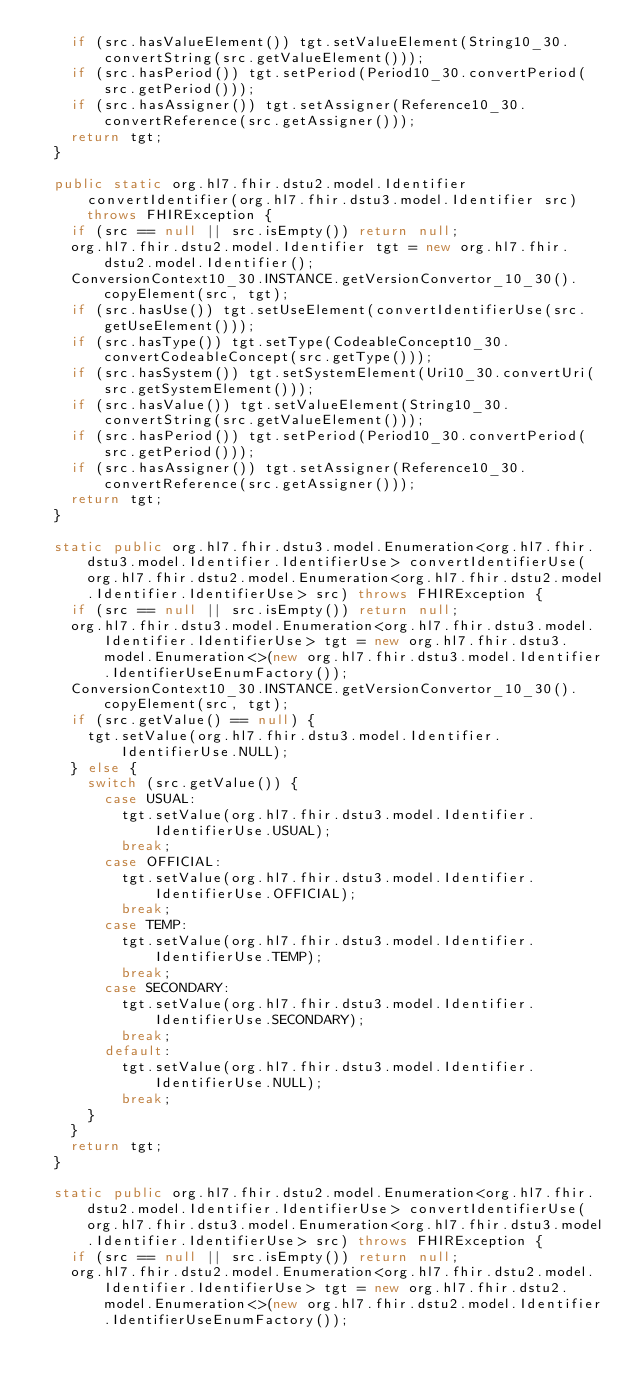<code> <loc_0><loc_0><loc_500><loc_500><_Java_>    if (src.hasValueElement()) tgt.setValueElement(String10_30.convertString(src.getValueElement()));
    if (src.hasPeriod()) tgt.setPeriod(Period10_30.convertPeriod(src.getPeriod()));
    if (src.hasAssigner()) tgt.setAssigner(Reference10_30.convertReference(src.getAssigner()));
    return tgt;
  }

  public static org.hl7.fhir.dstu2.model.Identifier convertIdentifier(org.hl7.fhir.dstu3.model.Identifier src) throws FHIRException {
    if (src == null || src.isEmpty()) return null;
    org.hl7.fhir.dstu2.model.Identifier tgt = new org.hl7.fhir.dstu2.model.Identifier();
    ConversionContext10_30.INSTANCE.getVersionConvertor_10_30().copyElement(src, tgt);
    if (src.hasUse()) tgt.setUseElement(convertIdentifierUse(src.getUseElement()));
    if (src.hasType()) tgt.setType(CodeableConcept10_30.convertCodeableConcept(src.getType()));
    if (src.hasSystem()) tgt.setSystemElement(Uri10_30.convertUri(src.getSystemElement()));
    if (src.hasValue()) tgt.setValueElement(String10_30.convertString(src.getValueElement()));
    if (src.hasPeriod()) tgt.setPeriod(Period10_30.convertPeriod(src.getPeriod()));
    if (src.hasAssigner()) tgt.setAssigner(Reference10_30.convertReference(src.getAssigner()));
    return tgt;
  }

  static public org.hl7.fhir.dstu3.model.Enumeration<org.hl7.fhir.dstu3.model.Identifier.IdentifierUse> convertIdentifierUse(org.hl7.fhir.dstu2.model.Enumeration<org.hl7.fhir.dstu2.model.Identifier.IdentifierUse> src) throws FHIRException {
    if (src == null || src.isEmpty()) return null;
    org.hl7.fhir.dstu3.model.Enumeration<org.hl7.fhir.dstu3.model.Identifier.IdentifierUse> tgt = new org.hl7.fhir.dstu3.model.Enumeration<>(new org.hl7.fhir.dstu3.model.Identifier.IdentifierUseEnumFactory());
    ConversionContext10_30.INSTANCE.getVersionConvertor_10_30().copyElement(src, tgt);
    if (src.getValue() == null) {
      tgt.setValue(org.hl7.fhir.dstu3.model.Identifier.IdentifierUse.NULL);
    } else {
      switch (src.getValue()) {
        case USUAL:
          tgt.setValue(org.hl7.fhir.dstu3.model.Identifier.IdentifierUse.USUAL);
          break;
        case OFFICIAL:
          tgt.setValue(org.hl7.fhir.dstu3.model.Identifier.IdentifierUse.OFFICIAL);
          break;
        case TEMP:
          tgt.setValue(org.hl7.fhir.dstu3.model.Identifier.IdentifierUse.TEMP);
          break;
        case SECONDARY:
          tgt.setValue(org.hl7.fhir.dstu3.model.Identifier.IdentifierUse.SECONDARY);
          break;
        default:
          tgt.setValue(org.hl7.fhir.dstu3.model.Identifier.IdentifierUse.NULL);
          break;
      }
    }
    return tgt;
  }

  static public org.hl7.fhir.dstu2.model.Enumeration<org.hl7.fhir.dstu2.model.Identifier.IdentifierUse> convertIdentifierUse(org.hl7.fhir.dstu3.model.Enumeration<org.hl7.fhir.dstu3.model.Identifier.IdentifierUse> src) throws FHIRException {
    if (src == null || src.isEmpty()) return null;
    org.hl7.fhir.dstu2.model.Enumeration<org.hl7.fhir.dstu2.model.Identifier.IdentifierUse> tgt = new org.hl7.fhir.dstu2.model.Enumeration<>(new org.hl7.fhir.dstu2.model.Identifier.IdentifierUseEnumFactory());</code> 